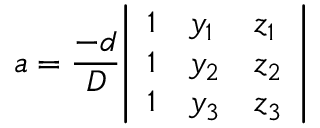<formula> <loc_0><loc_0><loc_500><loc_500>a = { \frac { - d } { D } } { \left | \begin{array} { l l l } { 1 } & { y _ { 1 } } & { z _ { 1 } } \\ { 1 } & { y _ { 2 } } & { z _ { 2 } } \\ { 1 } & { y _ { 3 } } & { z _ { 3 } } \end{array} \right | }</formula> 